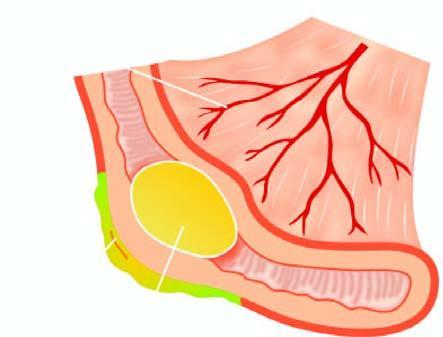did onsumption of tobacco in india open appendix showing impacted faecolith in the lumen and exudate on the serosa?
Answer the question using a single word or phrase. No 